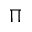<formula> <loc_0><loc_0><loc_500><loc_500>\Pi</formula> 